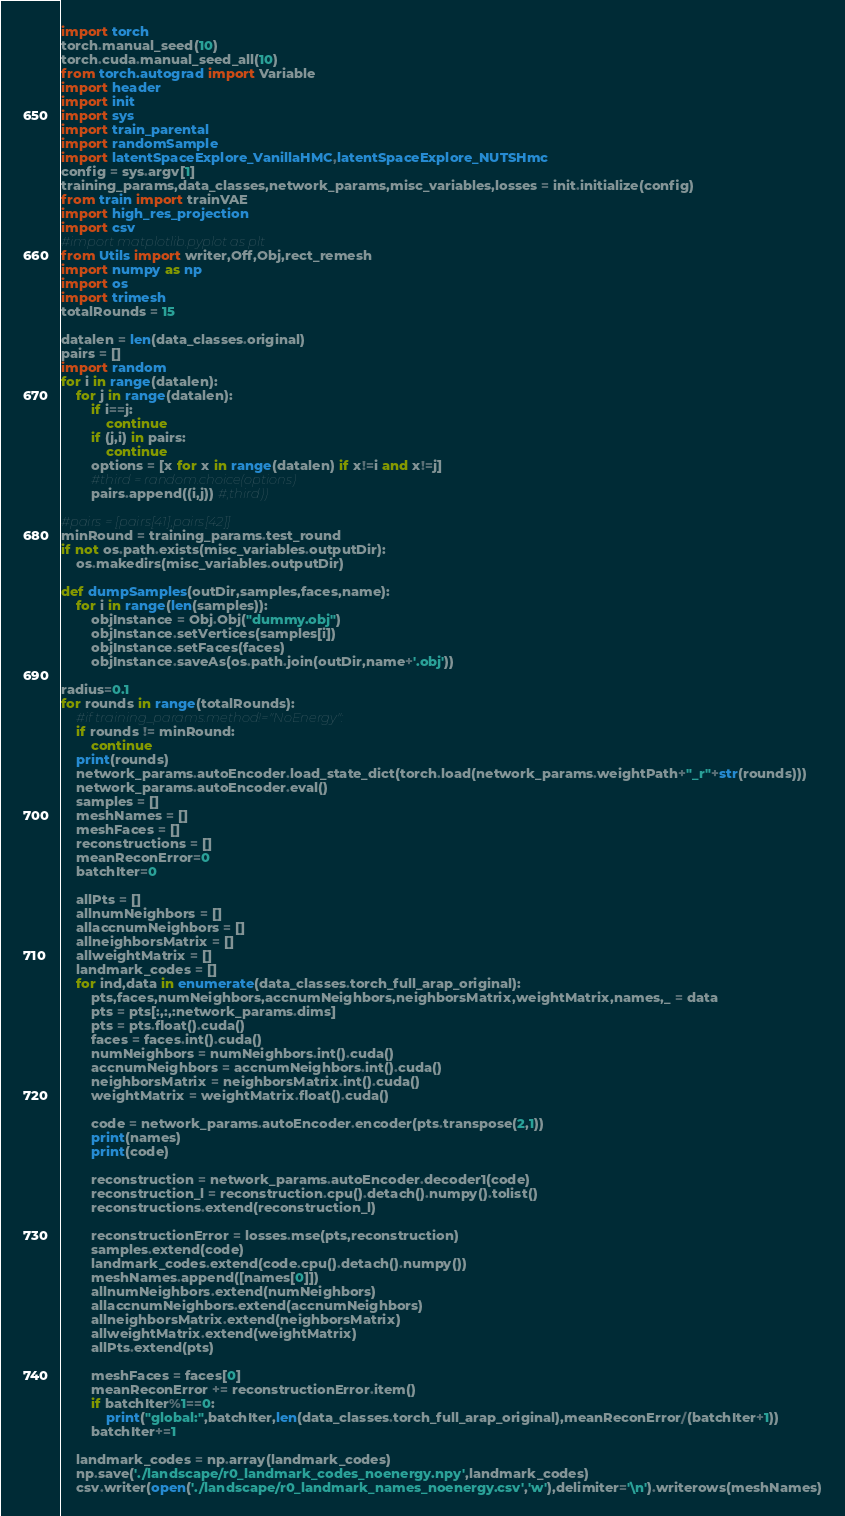Convert code to text. <code><loc_0><loc_0><loc_500><loc_500><_Python_>import torch
torch.manual_seed(10)
torch.cuda.manual_seed_all(10)
from torch.autograd import Variable
import header
import init
import sys
import train_parental
import randomSample
import latentSpaceExplore_VanillaHMC,latentSpaceExplore_NUTSHmc
config = sys.argv[1]
training_params,data_classes,network_params,misc_variables,losses = init.initialize(config)
from train import trainVAE
import high_res_projection
import csv 
#import matplotlib.pyplot as plt
from Utils import writer,Off,Obj,rect_remesh
import numpy as np
import os
import trimesh
totalRounds = 15

datalen = len(data_classes.original)
pairs = []
import random
for i in range(datalen):
    for j in range(datalen):
        if i==j:
            continue
        if (j,i) in pairs:
            continue
        options = [x for x in range(datalen) if x!=i and x!=j]
        #third = random.choice(options)
        pairs.append((i,j)) #,third))

#pairs = [pairs[41],pairs[42]]
minRound = training_params.test_round
if not os.path.exists(misc_variables.outputDir):
    os.makedirs(misc_variables.outputDir)

def dumpSamples(outDir,samples,faces,name):
    for i in range(len(samples)):
        objInstance = Obj.Obj("dummy.obj")
        objInstance.setVertices(samples[i])
        objInstance.setFaces(faces)
        objInstance.saveAs(os.path.join(outDir,name+'.obj'))

radius=0.1
for rounds in range(totalRounds):
    #if training_params.method!="NoEnergy":
    if rounds != minRound:
        continue
    print(rounds)
    network_params.autoEncoder.load_state_dict(torch.load(network_params.weightPath+"_r"+str(rounds)))
    network_params.autoEncoder.eval()
    samples = []
    meshNames = []
    meshFaces = []
    reconstructions = []
    meanReconError=0
    batchIter=0

    allPts = []
    allnumNeighbors = []
    allaccnumNeighbors = []
    allneighborsMatrix = []
    allweightMatrix = []
    landmark_codes = []
    for ind,data in enumerate(data_classes.torch_full_arap_original):
        pts,faces,numNeighbors,accnumNeighbors,neighborsMatrix,weightMatrix,names,_ = data
        pts = pts[:,:,:network_params.dims]
        pts = pts.float().cuda()
        faces = faces.int().cuda()
        numNeighbors = numNeighbors.int().cuda()
        accnumNeighbors = accnumNeighbors.int().cuda()
        neighborsMatrix = neighborsMatrix.int().cuda()
        weightMatrix = weightMatrix.float().cuda()

        code = network_params.autoEncoder.encoder(pts.transpose(2,1))
        print(names)
        print(code)

        reconstruction = network_params.autoEncoder.decoder1(code)
        reconstruction_l = reconstruction.cpu().detach().numpy().tolist()
        reconstructions.extend(reconstruction_l)
        
        reconstructionError = losses.mse(pts,reconstruction)
        samples.extend(code)
        landmark_codes.extend(code.cpu().detach().numpy())
        meshNames.append([names[0]])
        allnumNeighbors.extend(numNeighbors)
        allaccnumNeighbors.extend(accnumNeighbors)
        allneighborsMatrix.extend(neighborsMatrix)
        allweightMatrix.extend(weightMatrix)
        allPts.extend(pts)

        meshFaces = faces[0]
        meanReconError += reconstructionError.item()
        if batchIter%1==0:
            print("global:",batchIter,len(data_classes.torch_full_arap_original),meanReconError/(batchIter+1))
        batchIter+=1

    landmark_codes = np.array(landmark_codes)
    np.save('./landscape/r0_landmark_codes_noenergy.npy',landmark_codes)
    csv.writer(open('./landscape/r0_landmark_names_noenergy.csv','w'),delimiter='\n').writerows(meshNames)
</code> 